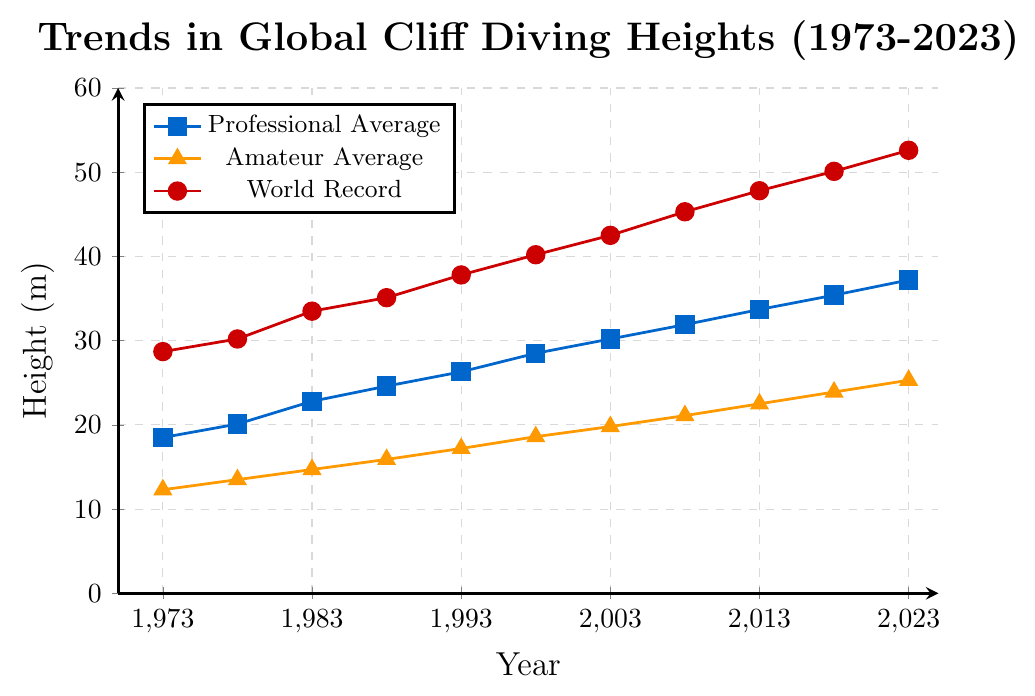What is the professional average height in 1973? Look at the beginning of the blue line for the professional average, which starts at the value corresponding to 1973.
Answer: 18.5 m What trend can be observed in the world record heights over the past 50 years? Examine the progression of the red line, representing the world record heights, from 1973 to 2023.
Answer: Increasing trend By how much did the amateur average height increase from 1973 to 2023? Find the amateur average height for 2023 and subtract the amateur average height for 1973 from it (25.3 - 12.3).
Answer: 13 m Which year shows the biggest increase in professional average height compared to the previous data point? Calculate the differences between consecutive years' professional average heights in the blue line and find the largest difference. (20.1 - 18.5, 22.8 - 20.1, etc.).
Answer: 1993 to 1998 How does the amateur average height in 2023 compare to the professional average height in 1973? Compare the values at 2023 for amateurs (orange line) and at 1973 for professionals (blue line).
Answer: Higher by 6.8 m (25.3 vs 18.5) What's the difference between the world record height and the professional average height in 2023? Subtract the professional average height from the world record height for the year 2023 (52.6 - 37.2).
Answer: 15.4 m What was the height of the world record dive in 1993? Look at the red line and find the value corresponding to 1993.
Answer: 37.8 m Which category shows the steepest slope around 1998, and what might that indicate? Examine the slopes of the blue, orange, and red lines around the year 1998. The steepest slope indicates the most rapid increase.
Answer: Professional category indicates rapid improvement What is the combined average height for professionals and amateurs in 2013? Add the professional and amateur average heights for 2013 and divide by 2 ((33.7 + 22.5)/2).
Answer: 28.1 m Which year had the smallest gap between professional average height and amateur average height? Calculate differences for each year and find the minimum gap (e.g., 18.5 - 12.3, 20.1 - 13.5, etc.).
Answer: 1993 